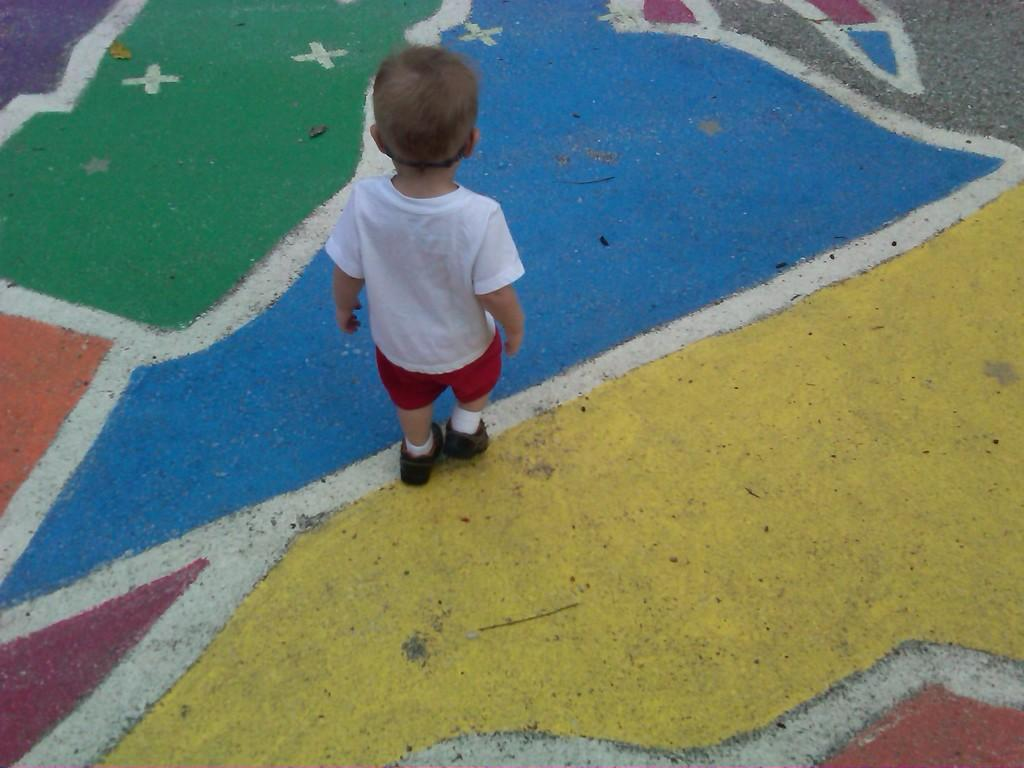What is the main subject of the image? The main subject of the image is a kid. What is the kid doing in the image? The kid is standing in the image. What can be observed about the surface the kid is standing on? The surface the kid is standing on is colorful. What type of shock can be seen affecting the kid in the image? There is no shock present in the image; the kid is simply standing on a colorful surface. Can you describe the wilderness surrounding the kid in the image? There is no wilderness present in the image; the kid is standing on a colorful surface, but no surrounding environment is visible. 